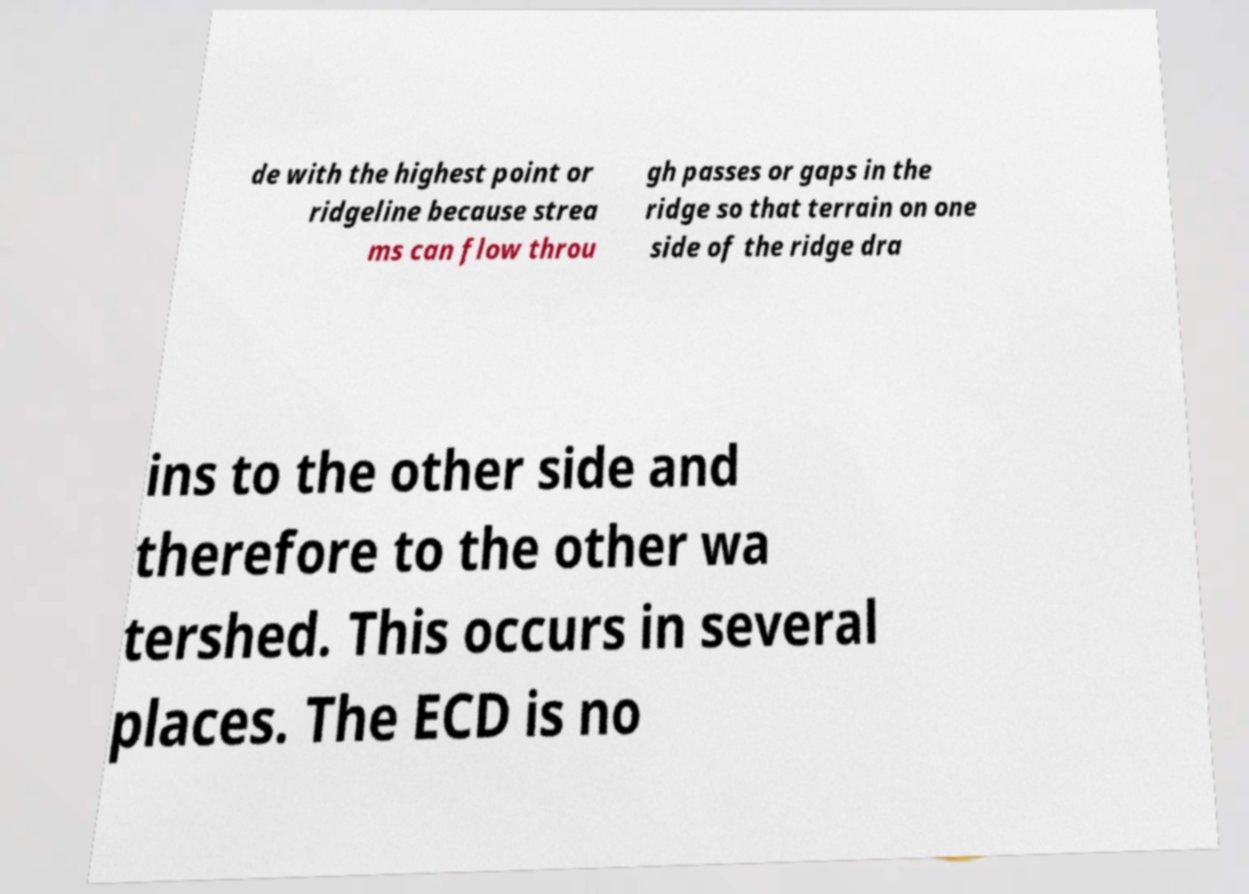For documentation purposes, I need the text within this image transcribed. Could you provide that? de with the highest point or ridgeline because strea ms can flow throu gh passes or gaps in the ridge so that terrain on one side of the ridge dra ins to the other side and therefore to the other wa tershed. This occurs in several places. The ECD is no 